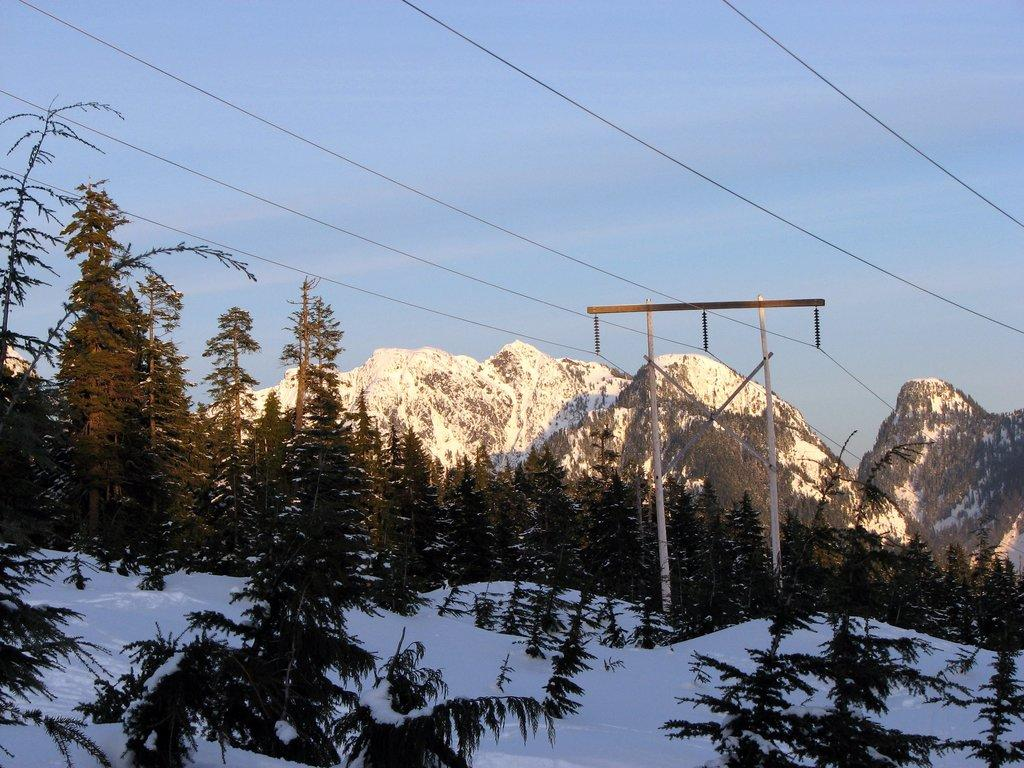What type of vegetation is present in the image? There are trees in the image. What color are the trees? The trees are green. What weather condition is depicted in the image? There is snow in the image. What color is the snow? The snow is white. What can be seen in the distance in the image? There are mountains in the background of the image. What color is the sky in the image? The sky is blue. What type of curtain can be seen hanging from the trees in the image? There are no curtains present in the image; it features trees, snow, mountains, and a blue sky. What type of seed is visible on the tongue of the person in the image? There is no person or tongue present in the image. 